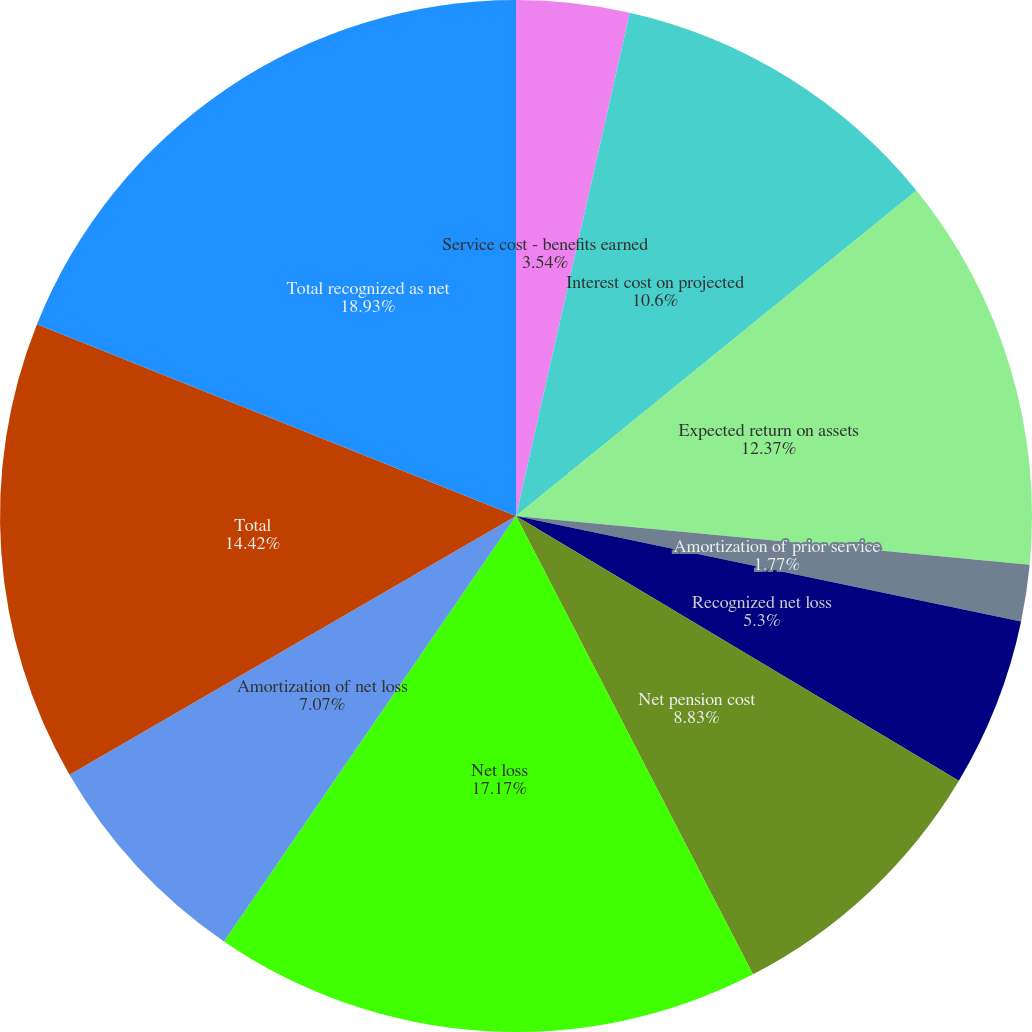<chart> <loc_0><loc_0><loc_500><loc_500><pie_chart><fcel>Service cost - benefits earned<fcel>Interest cost on projected<fcel>Expected return on assets<fcel>Amortization of prior service<fcel>Recognized net loss<fcel>Net pension cost<fcel>Net loss<fcel>Amortization of net loss<fcel>Total<fcel>Total recognized as net<nl><fcel>3.54%<fcel>10.6%<fcel>12.37%<fcel>1.77%<fcel>5.3%<fcel>8.83%<fcel>17.17%<fcel>7.07%<fcel>14.42%<fcel>18.94%<nl></chart> 